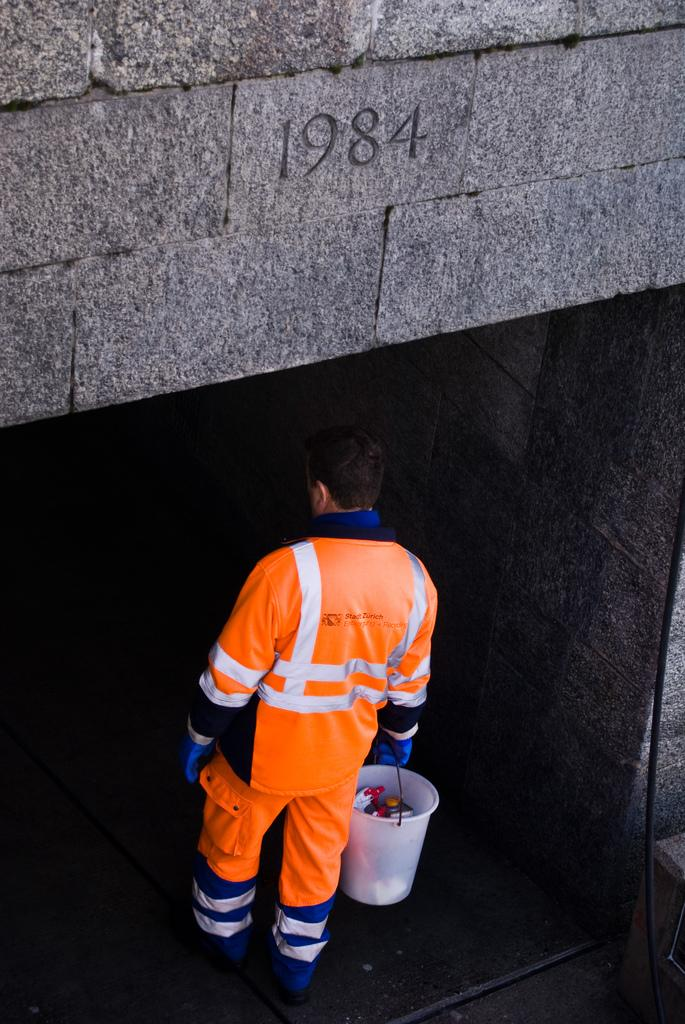Provide a one-sentence caption for the provided image. A man in an orange Stadt Zurich uniform is walking into a tunnel that says 1984. 